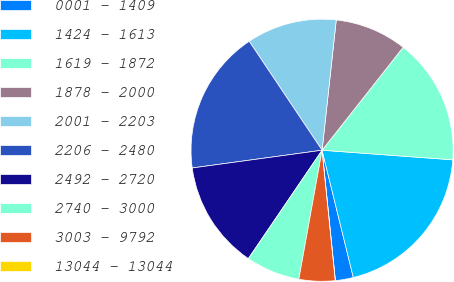Convert chart. <chart><loc_0><loc_0><loc_500><loc_500><pie_chart><fcel>0001 - 1409<fcel>1424 - 1613<fcel>1619 - 1872<fcel>1878 - 2000<fcel>2001 - 2203<fcel>2206 - 2480<fcel>2492 - 2720<fcel>2740 - 3000<fcel>3003 - 9792<fcel>13044 - 13044<nl><fcel>2.22%<fcel>20.0%<fcel>15.55%<fcel>8.89%<fcel>11.11%<fcel>17.78%<fcel>13.33%<fcel>6.67%<fcel>4.45%<fcel>0.0%<nl></chart> 